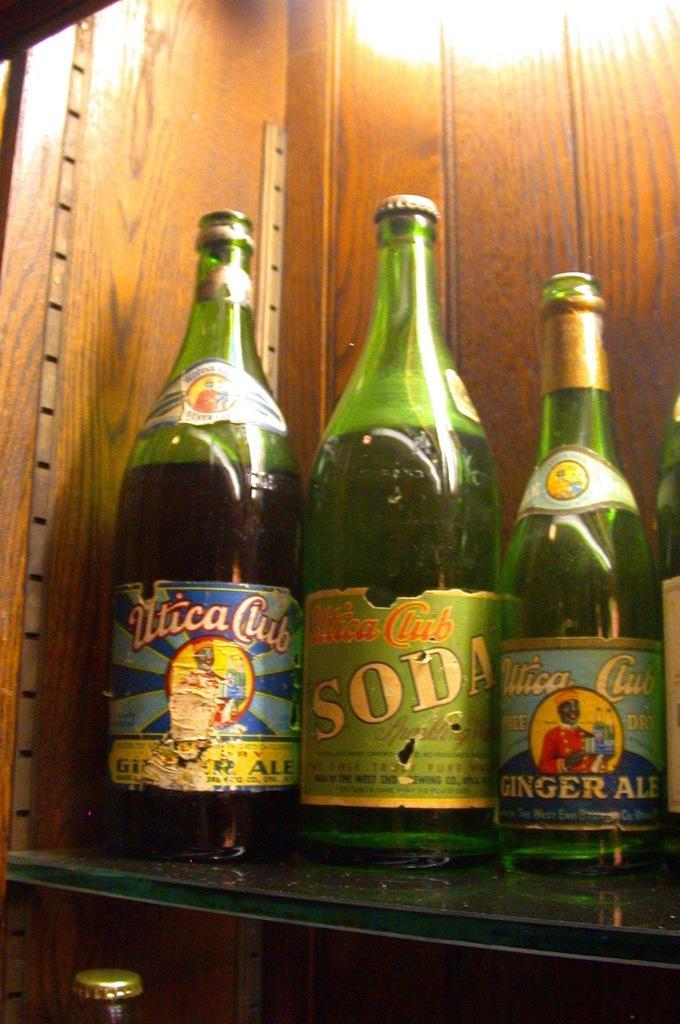Please provide a concise description of this image. there are so many bottles on a table. 